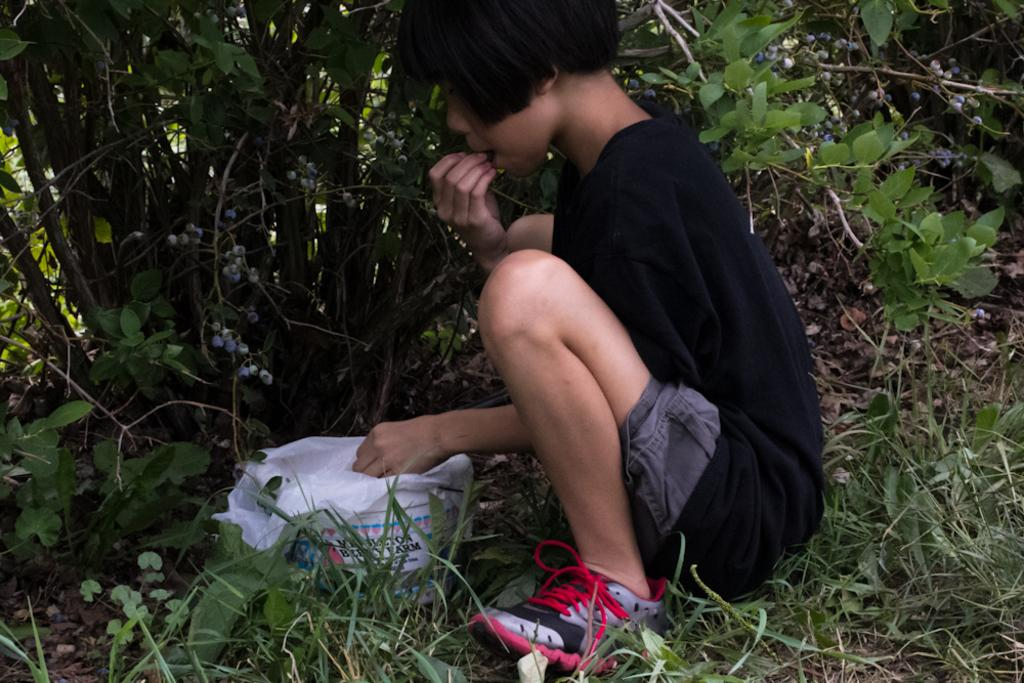What is the main subject of the image? The main subject of the image is a kid. What is the kid wearing in the image? The kid is wearing a black dress in the image. What is the kid doing in the image? The kid is sitting in the image. What type of surface is the kid sitting on? The ground is covered with grass in the image. What can be seen in the background of the image? There are plants in the background of the image. What type of glove is the kid wearing in the image? There is no glove visible in the image; the kid is wearing a black dress. What type of club is the kid holding in the image? There is no club present in the image; the kid is sitting and not holding any objects. 